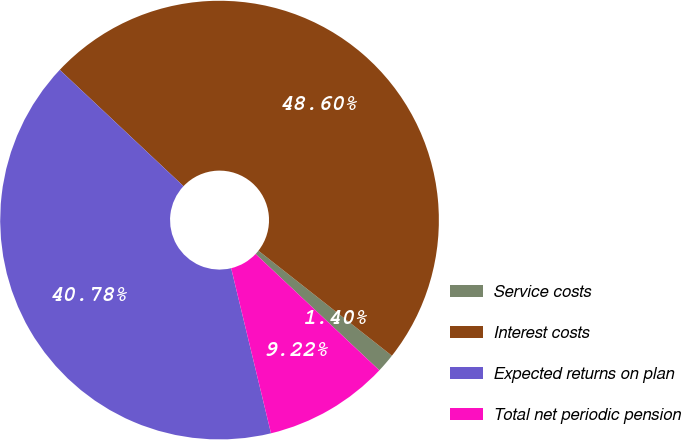Convert chart to OTSL. <chart><loc_0><loc_0><loc_500><loc_500><pie_chart><fcel>Service costs<fcel>Interest costs<fcel>Expected returns on plan<fcel>Total net periodic pension<nl><fcel>1.4%<fcel>48.6%<fcel>40.78%<fcel>9.22%<nl></chart> 